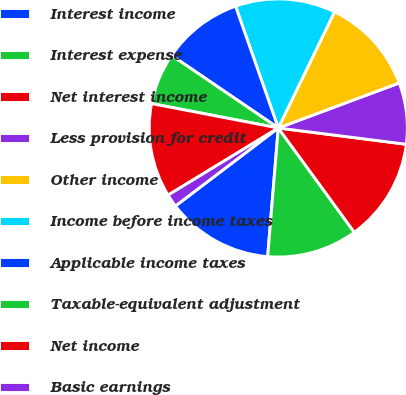Convert chart to OTSL. <chart><loc_0><loc_0><loc_500><loc_500><pie_chart><fcel>Interest income<fcel>Interest expense<fcel>Net interest income<fcel>Less provision for credit<fcel>Other income<fcel>Income before income taxes<fcel>Applicable income taxes<fcel>Taxable-equivalent adjustment<fcel>Net income<fcel>Basic earnings<nl><fcel>13.36%<fcel>11.34%<fcel>12.96%<fcel>7.69%<fcel>12.15%<fcel>12.55%<fcel>10.12%<fcel>6.48%<fcel>11.74%<fcel>1.62%<nl></chart> 